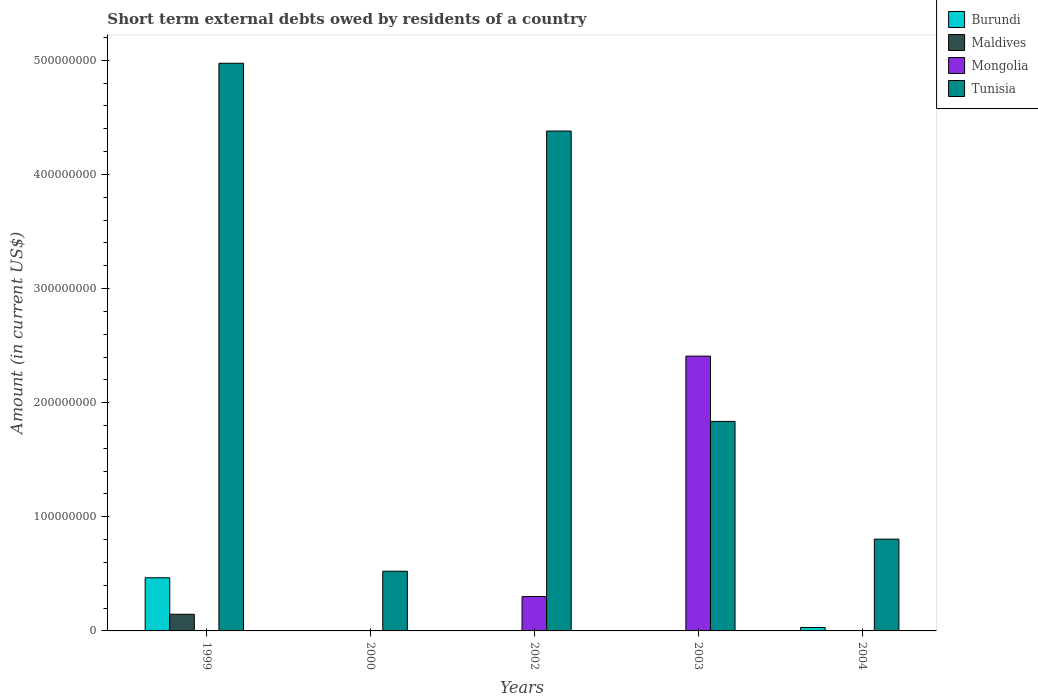How many different coloured bars are there?
Make the answer very short. 4. Are the number of bars per tick equal to the number of legend labels?
Give a very brief answer. No. Are the number of bars on each tick of the X-axis equal?
Provide a short and direct response. No. How many bars are there on the 5th tick from the left?
Your response must be concise. 2. In how many cases, is the number of bars for a given year not equal to the number of legend labels?
Make the answer very short. 5. What is the amount of short-term external debts owed by residents in Mongolia in 2004?
Your answer should be very brief. 0. Across all years, what is the maximum amount of short-term external debts owed by residents in Mongolia?
Keep it short and to the point. 2.41e+08. Across all years, what is the minimum amount of short-term external debts owed by residents in Mongolia?
Make the answer very short. 0. What is the total amount of short-term external debts owed by residents in Burundi in the graph?
Give a very brief answer. 4.96e+07. What is the difference between the amount of short-term external debts owed by residents in Tunisia in 1999 and that in 2003?
Your answer should be compact. 3.14e+08. What is the difference between the amount of short-term external debts owed by residents in Burundi in 2003 and the amount of short-term external debts owed by residents in Maldives in 1999?
Ensure brevity in your answer.  -1.46e+07. What is the average amount of short-term external debts owed by residents in Mongolia per year?
Ensure brevity in your answer.  5.42e+07. In the year 1999, what is the difference between the amount of short-term external debts owed by residents in Burundi and amount of short-term external debts owed by residents in Maldives?
Offer a very short reply. 3.20e+07. What is the ratio of the amount of short-term external debts owed by residents in Tunisia in 2002 to that in 2004?
Provide a short and direct response. 5.45. Is the amount of short-term external debts owed by residents in Mongolia in 2002 less than that in 2003?
Your answer should be very brief. Yes. What is the difference between the highest and the second highest amount of short-term external debts owed by residents in Tunisia?
Make the answer very short. 5.94e+07. What is the difference between the highest and the lowest amount of short-term external debts owed by residents in Tunisia?
Offer a very short reply. 4.45e+08. Is it the case that in every year, the sum of the amount of short-term external debts owed by residents in Maldives and amount of short-term external debts owed by residents in Tunisia is greater than the amount of short-term external debts owed by residents in Mongolia?
Your response must be concise. No. Are all the bars in the graph horizontal?
Offer a very short reply. No. How many years are there in the graph?
Your answer should be compact. 5. What is the difference between two consecutive major ticks on the Y-axis?
Your answer should be very brief. 1.00e+08. Are the values on the major ticks of Y-axis written in scientific E-notation?
Offer a very short reply. No. Does the graph contain any zero values?
Make the answer very short. Yes. Where does the legend appear in the graph?
Offer a terse response. Top right. How many legend labels are there?
Keep it short and to the point. 4. How are the legend labels stacked?
Your answer should be compact. Vertical. What is the title of the graph?
Your answer should be very brief. Short term external debts owed by residents of a country. Does "Europe(all income levels)" appear as one of the legend labels in the graph?
Offer a very short reply. No. What is the label or title of the X-axis?
Ensure brevity in your answer.  Years. What is the Amount (in current US$) in Burundi in 1999?
Ensure brevity in your answer.  4.66e+07. What is the Amount (in current US$) in Maldives in 1999?
Your answer should be very brief. 1.46e+07. What is the Amount (in current US$) in Tunisia in 1999?
Ensure brevity in your answer.  4.97e+08. What is the Amount (in current US$) of Maldives in 2000?
Your answer should be very brief. 0. What is the Amount (in current US$) of Mongolia in 2000?
Offer a very short reply. 0. What is the Amount (in current US$) of Tunisia in 2000?
Ensure brevity in your answer.  5.23e+07. What is the Amount (in current US$) in Mongolia in 2002?
Your answer should be compact. 3.01e+07. What is the Amount (in current US$) of Tunisia in 2002?
Ensure brevity in your answer.  4.38e+08. What is the Amount (in current US$) of Mongolia in 2003?
Your answer should be very brief. 2.41e+08. What is the Amount (in current US$) of Tunisia in 2003?
Ensure brevity in your answer.  1.84e+08. What is the Amount (in current US$) of Burundi in 2004?
Provide a short and direct response. 3.00e+06. What is the Amount (in current US$) in Maldives in 2004?
Your answer should be compact. 0. What is the Amount (in current US$) in Mongolia in 2004?
Ensure brevity in your answer.  0. What is the Amount (in current US$) in Tunisia in 2004?
Provide a short and direct response. 8.04e+07. Across all years, what is the maximum Amount (in current US$) of Burundi?
Give a very brief answer. 4.66e+07. Across all years, what is the maximum Amount (in current US$) of Maldives?
Provide a short and direct response. 1.46e+07. Across all years, what is the maximum Amount (in current US$) in Mongolia?
Your answer should be compact. 2.41e+08. Across all years, what is the maximum Amount (in current US$) in Tunisia?
Your answer should be very brief. 4.97e+08. Across all years, what is the minimum Amount (in current US$) in Burundi?
Provide a succinct answer. 0. Across all years, what is the minimum Amount (in current US$) of Tunisia?
Keep it short and to the point. 5.23e+07. What is the total Amount (in current US$) in Burundi in the graph?
Keep it short and to the point. 4.96e+07. What is the total Amount (in current US$) in Maldives in the graph?
Ensure brevity in your answer.  1.46e+07. What is the total Amount (in current US$) of Mongolia in the graph?
Make the answer very short. 2.71e+08. What is the total Amount (in current US$) of Tunisia in the graph?
Make the answer very short. 1.25e+09. What is the difference between the Amount (in current US$) in Tunisia in 1999 and that in 2000?
Your answer should be compact. 4.45e+08. What is the difference between the Amount (in current US$) in Tunisia in 1999 and that in 2002?
Your answer should be very brief. 5.94e+07. What is the difference between the Amount (in current US$) of Tunisia in 1999 and that in 2003?
Give a very brief answer. 3.14e+08. What is the difference between the Amount (in current US$) of Burundi in 1999 and that in 2004?
Provide a succinct answer. 4.36e+07. What is the difference between the Amount (in current US$) of Tunisia in 1999 and that in 2004?
Ensure brevity in your answer.  4.17e+08. What is the difference between the Amount (in current US$) of Tunisia in 2000 and that in 2002?
Your answer should be compact. -3.86e+08. What is the difference between the Amount (in current US$) in Tunisia in 2000 and that in 2003?
Give a very brief answer. -1.31e+08. What is the difference between the Amount (in current US$) in Tunisia in 2000 and that in 2004?
Make the answer very short. -2.81e+07. What is the difference between the Amount (in current US$) in Mongolia in 2002 and that in 2003?
Your response must be concise. -2.11e+08. What is the difference between the Amount (in current US$) of Tunisia in 2002 and that in 2003?
Give a very brief answer. 2.54e+08. What is the difference between the Amount (in current US$) in Tunisia in 2002 and that in 2004?
Your response must be concise. 3.58e+08. What is the difference between the Amount (in current US$) of Tunisia in 2003 and that in 2004?
Give a very brief answer. 1.03e+08. What is the difference between the Amount (in current US$) in Burundi in 1999 and the Amount (in current US$) in Tunisia in 2000?
Make the answer very short. -5.76e+06. What is the difference between the Amount (in current US$) in Maldives in 1999 and the Amount (in current US$) in Tunisia in 2000?
Offer a terse response. -3.77e+07. What is the difference between the Amount (in current US$) of Burundi in 1999 and the Amount (in current US$) of Mongolia in 2002?
Offer a very short reply. 1.65e+07. What is the difference between the Amount (in current US$) in Burundi in 1999 and the Amount (in current US$) in Tunisia in 2002?
Provide a succinct answer. -3.91e+08. What is the difference between the Amount (in current US$) in Maldives in 1999 and the Amount (in current US$) in Mongolia in 2002?
Make the answer very short. -1.55e+07. What is the difference between the Amount (in current US$) of Maldives in 1999 and the Amount (in current US$) of Tunisia in 2002?
Offer a terse response. -4.23e+08. What is the difference between the Amount (in current US$) of Burundi in 1999 and the Amount (in current US$) of Mongolia in 2003?
Provide a succinct answer. -1.94e+08. What is the difference between the Amount (in current US$) of Burundi in 1999 and the Amount (in current US$) of Tunisia in 2003?
Give a very brief answer. -1.37e+08. What is the difference between the Amount (in current US$) in Maldives in 1999 and the Amount (in current US$) in Mongolia in 2003?
Your answer should be compact. -2.26e+08. What is the difference between the Amount (in current US$) of Maldives in 1999 and the Amount (in current US$) of Tunisia in 2003?
Your answer should be compact. -1.69e+08. What is the difference between the Amount (in current US$) of Burundi in 1999 and the Amount (in current US$) of Tunisia in 2004?
Give a very brief answer. -3.39e+07. What is the difference between the Amount (in current US$) in Maldives in 1999 and the Amount (in current US$) in Tunisia in 2004?
Your answer should be very brief. -6.58e+07. What is the difference between the Amount (in current US$) of Mongolia in 2002 and the Amount (in current US$) of Tunisia in 2003?
Your answer should be compact. -1.53e+08. What is the difference between the Amount (in current US$) of Mongolia in 2002 and the Amount (in current US$) of Tunisia in 2004?
Offer a terse response. -5.03e+07. What is the difference between the Amount (in current US$) in Mongolia in 2003 and the Amount (in current US$) in Tunisia in 2004?
Make the answer very short. 1.60e+08. What is the average Amount (in current US$) in Burundi per year?
Keep it short and to the point. 9.91e+06. What is the average Amount (in current US$) in Maldives per year?
Ensure brevity in your answer.  2.92e+06. What is the average Amount (in current US$) of Mongolia per year?
Provide a short and direct response. 5.42e+07. What is the average Amount (in current US$) in Tunisia per year?
Give a very brief answer. 2.50e+08. In the year 1999, what is the difference between the Amount (in current US$) of Burundi and Amount (in current US$) of Maldives?
Provide a succinct answer. 3.20e+07. In the year 1999, what is the difference between the Amount (in current US$) of Burundi and Amount (in current US$) of Tunisia?
Your response must be concise. -4.51e+08. In the year 1999, what is the difference between the Amount (in current US$) of Maldives and Amount (in current US$) of Tunisia?
Ensure brevity in your answer.  -4.83e+08. In the year 2002, what is the difference between the Amount (in current US$) in Mongolia and Amount (in current US$) in Tunisia?
Your answer should be compact. -4.08e+08. In the year 2003, what is the difference between the Amount (in current US$) of Mongolia and Amount (in current US$) of Tunisia?
Make the answer very short. 5.72e+07. In the year 2004, what is the difference between the Amount (in current US$) in Burundi and Amount (in current US$) in Tunisia?
Your response must be concise. -7.74e+07. What is the ratio of the Amount (in current US$) in Tunisia in 1999 to that in 2000?
Keep it short and to the point. 9.51. What is the ratio of the Amount (in current US$) in Tunisia in 1999 to that in 2002?
Offer a terse response. 1.14. What is the ratio of the Amount (in current US$) in Tunisia in 1999 to that in 2003?
Your response must be concise. 2.71. What is the ratio of the Amount (in current US$) in Burundi in 1999 to that in 2004?
Provide a succinct answer. 15.52. What is the ratio of the Amount (in current US$) in Tunisia in 1999 to that in 2004?
Offer a terse response. 6.18. What is the ratio of the Amount (in current US$) of Tunisia in 2000 to that in 2002?
Your answer should be very brief. 0.12. What is the ratio of the Amount (in current US$) of Tunisia in 2000 to that in 2003?
Offer a terse response. 0.28. What is the ratio of the Amount (in current US$) of Tunisia in 2000 to that in 2004?
Give a very brief answer. 0.65. What is the ratio of the Amount (in current US$) of Tunisia in 2002 to that in 2003?
Keep it short and to the point. 2.39. What is the ratio of the Amount (in current US$) of Tunisia in 2002 to that in 2004?
Your answer should be compact. 5.45. What is the ratio of the Amount (in current US$) in Tunisia in 2003 to that in 2004?
Keep it short and to the point. 2.28. What is the difference between the highest and the second highest Amount (in current US$) of Tunisia?
Make the answer very short. 5.94e+07. What is the difference between the highest and the lowest Amount (in current US$) in Burundi?
Ensure brevity in your answer.  4.66e+07. What is the difference between the highest and the lowest Amount (in current US$) in Maldives?
Offer a very short reply. 1.46e+07. What is the difference between the highest and the lowest Amount (in current US$) in Mongolia?
Your answer should be very brief. 2.41e+08. What is the difference between the highest and the lowest Amount (in current US$) of Tunisia?
Give a very brief answer. 4.45e+08. 